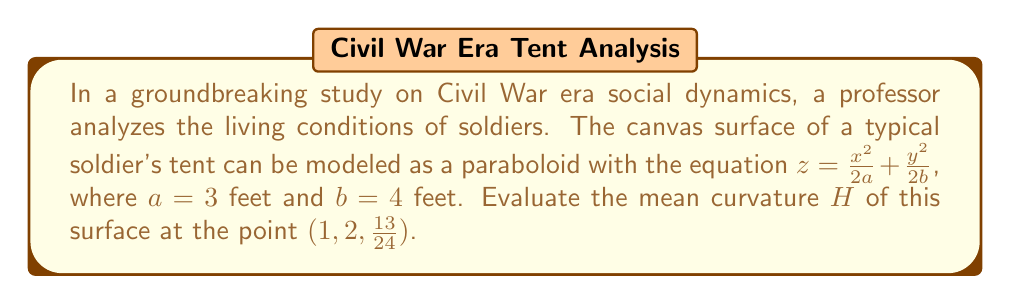Give your solution to this math problem. To evaluate the mean curvature of the tent canvas surface, we'll follow these steps:

1) The mean curvature $H$ is given by the formula:

   $$H = \frac{1}{2} \left(\frac{(1+f_y^2)f_{xx} - 2f_xf_yf_{xy} + (1+f_x^2)f_{yy}}{(1+f_x^2+f_y^2)^{3/2}}\right)$$

   where $f_x, f_y$ are first partial derivatives and $f_{xx}, f_{xy}, f_{yy}$ are second partial derivatives.

2) For our surface $z = \frac{x^2}{2a} + \frac{y^2}{2b}$, let's calculate these derivatives:

   $f_x = \frac{x}{a}$, $f_y = \frac{y}{b}$
   $f_{xx} = \frac{1}{a}$, $f_{yy} = \frac{1}{b}$, $f_{xy} = 0$

3) Substitute $a = 3$ and $b = 4$:

   $f_x = \frac{x}{3}$, $f_y = \frac{y}{4}$
   $f_{xx} = \frac{1}{3}$, $f_{yy} = \frac{1}{4}$, $f_{xy} = 0$

4) At the point $(1, 2, \frac{13}{24})$:

   $f_x = \frac{1}{3}$, $f_y = \frac{1}{2}$

5) Now, let's substitute these values into the mean curvature formula:

   $$H = \frac{1}{2} \left(\frac{(1+(\frac{1}{2})^2)\frac{1}{3} - 2(\frac{1}{3})(\frac{1}{2})(0) + (1+(\frac{1}{3})^2)\frac{1}{4}}{(1+(\frac{1}{3})^2+(\frac{1}{2})^2)^{3/2}}\right)$$

6) Simplify:

   $$H = \frac{1}{2} \left(\frac{\frac{5}{4}\cdot\frac{1}{3} + \frac{10}{9}\cdot\frac{1}{4}}{(\frac{49}{36})^{3/2}}\right)$$

7) Calculate:

   $$H = \frac{1}{2} \left(\frac{\frac{5}{12} + \frac{10}{36}}{(\frac{7}{6})^3}\right) = \frac{1}{2} \left(\frac{\frac{25}{36}}{(\frac{343}{216})}\right) = \frac{1}{2} \cdot \frac{25}{36} \cdot \frac{216}{343} = \frac{75}{686}$$
Answer: $\frac{75}{686}$ 